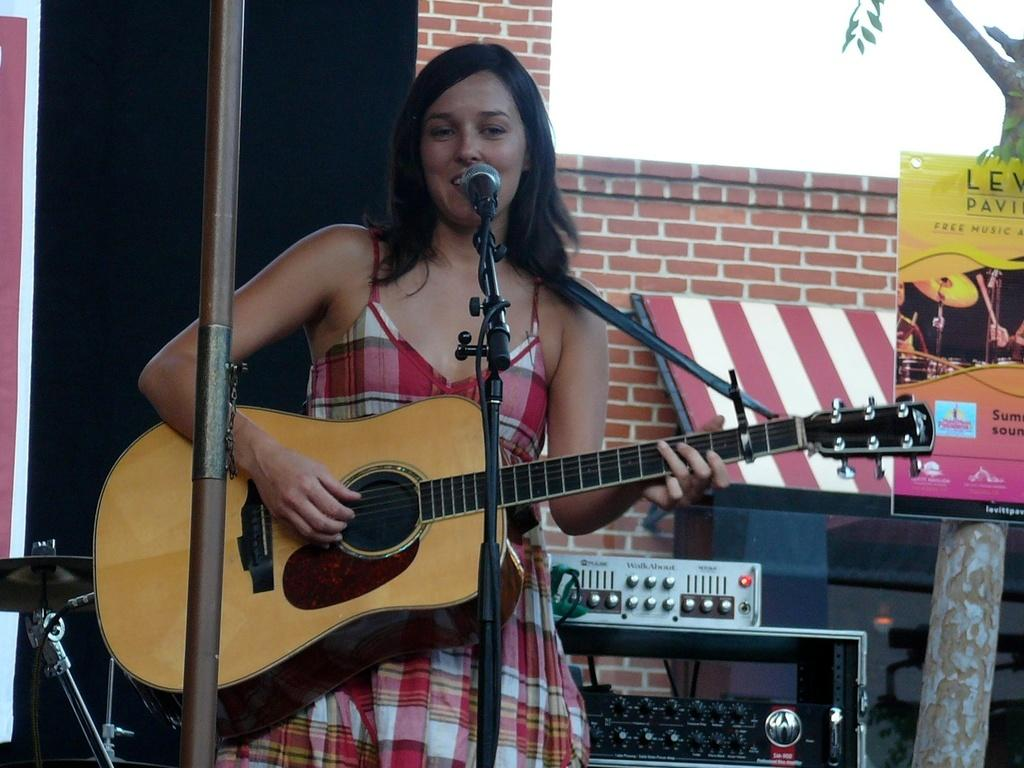Who is the main subject in the image? There is a woman in the image. What is the woman doing in the image? The woman is standing and holding a guitar. What object is present in the image that is typically used for amplifying sound? There is a microphone in the image. What object is present in the image that is used for holding or displaying something? There is a stand in the image. What type of tongue can be seen sticking out of the guitar in the image? There is no tongue, either human or animal, sticking out of the guitar in the image. 